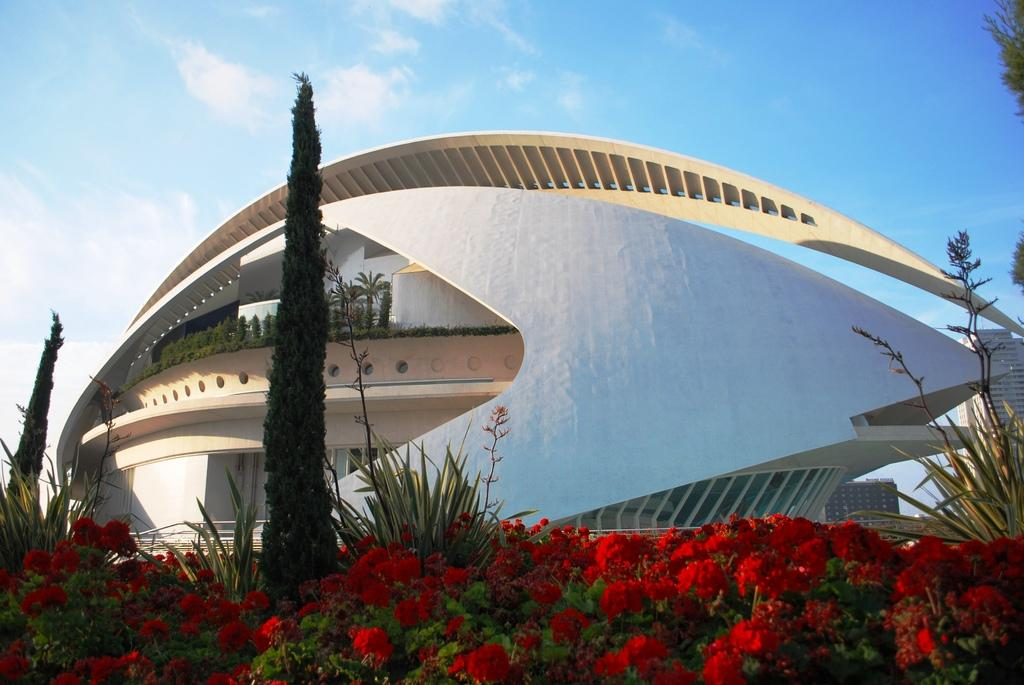What type of flowers can be seen in the front of the image? There are roses in the front of the image. What other plants are visible in the front of the image? There are plants in the front of the image. What can be seen in the background of the image? There is a building in the background of the image. How would you describe the sky in the image? The sky is cloudy in the image. What type of punishment is being carried out in the image? There is no indication of punishment in the image; it features roses, plants, a building, and a cloudy sky. Can you describe the room where the exchange is taking place in the image? There is no room or exchange present in the image. 